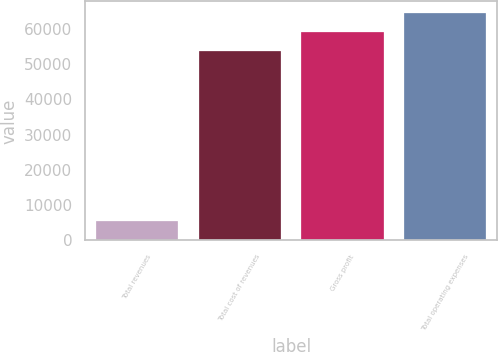<chart> <loc_0><loc_0><loc_500><loc_500><bar_chart><fcel>Total revenues<fcel>Total cost of revenues<fcel>Gross profit<fcel>Total operating expenses<nl><fcel>5617<fcel>53552<fcel>59169<fcel>64524.2<nl></chart> 